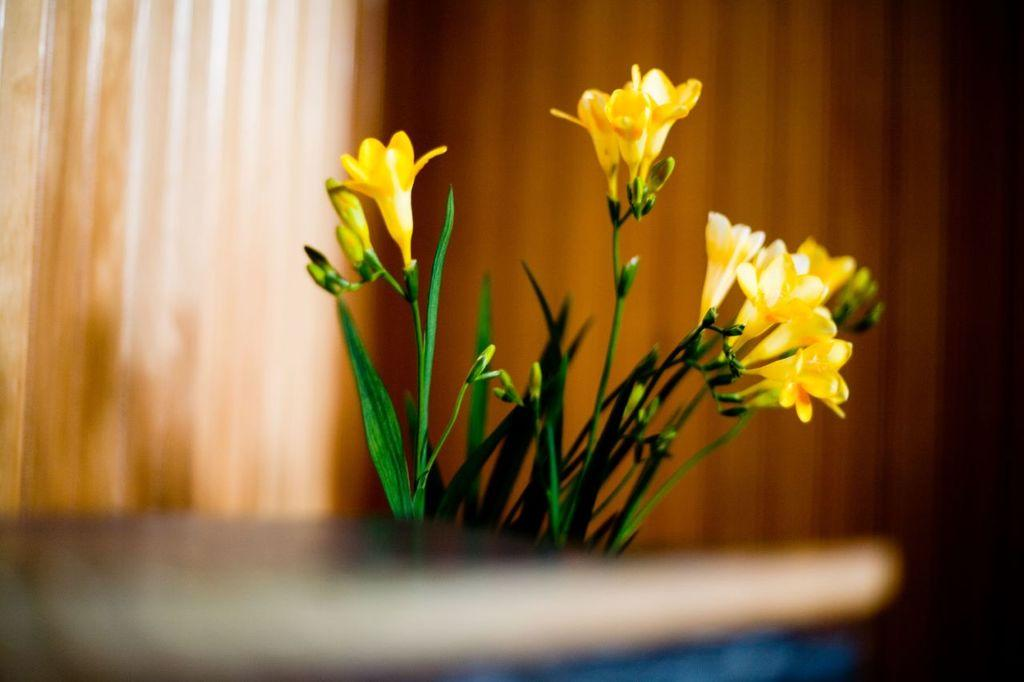What color are the flowers in the image? The flowers in the image are yellow. What other plant can be seen in the image? There is a small plant in green color in the image. How would you describe the background of the image? The background of the image appears blurred. What type of structure is visible in the background of the image? There is no structure visible in the background of the image; it appears blurred. Can you recite a verse that is written on the flowers in the image? There are no verses written on the flowers in the image; they are simply flowers. 